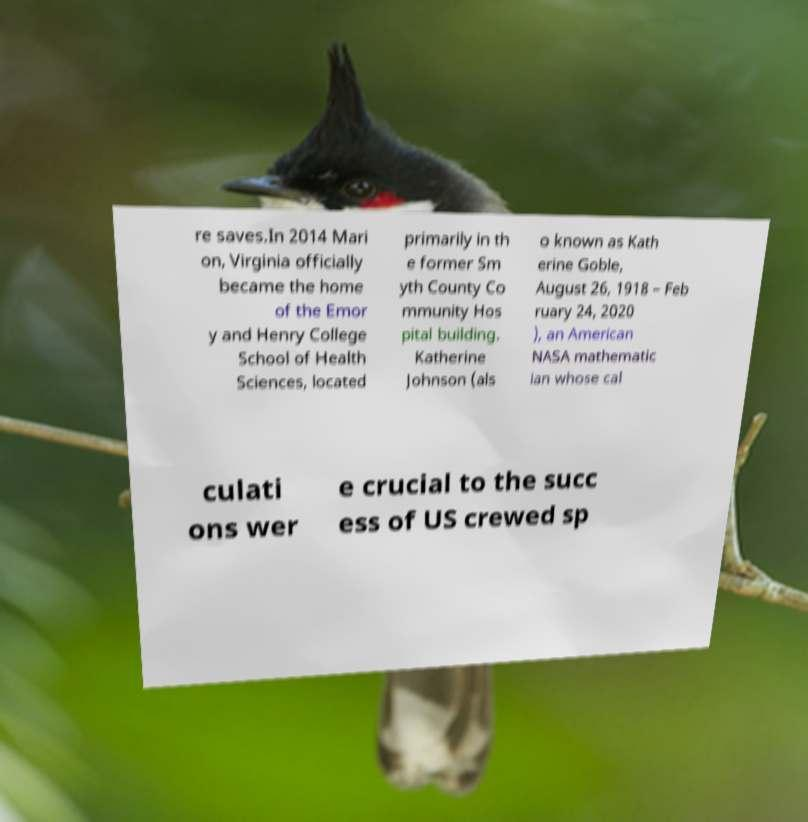Can you accurately transcribe the text from the provided image for me? re saves.In 2014 Mari on, Virginia officially became the home of the Emor y and Henry College School of Health Sciences, located primarily in th e former Sm yth County Co mmunity Hos pital building. Katherine Johnson (als o known as Kath erine Goble, August 26, 1918 – Feb ruary 24, 2020 ), an American NASA mathematic ian whose cal culati ons wer e crucial to the succ ess of US crewed sp 